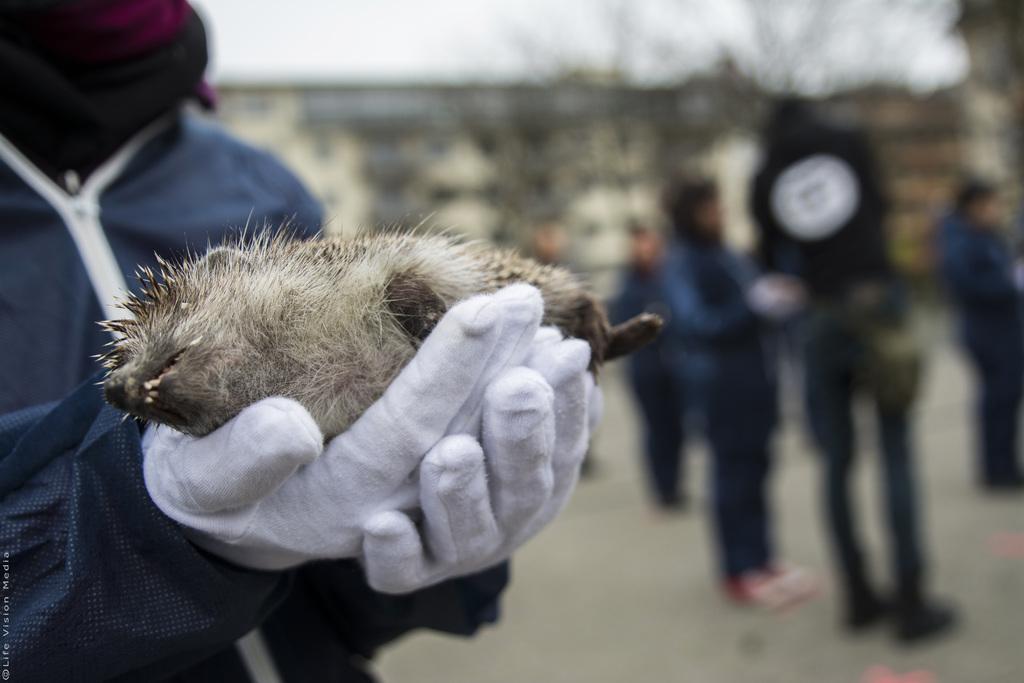Describe this image in one or two sentences. On the left side of the image a person is standing and holding something in his hand. On the right side of the image few people are standing. Background of the image is blur. 